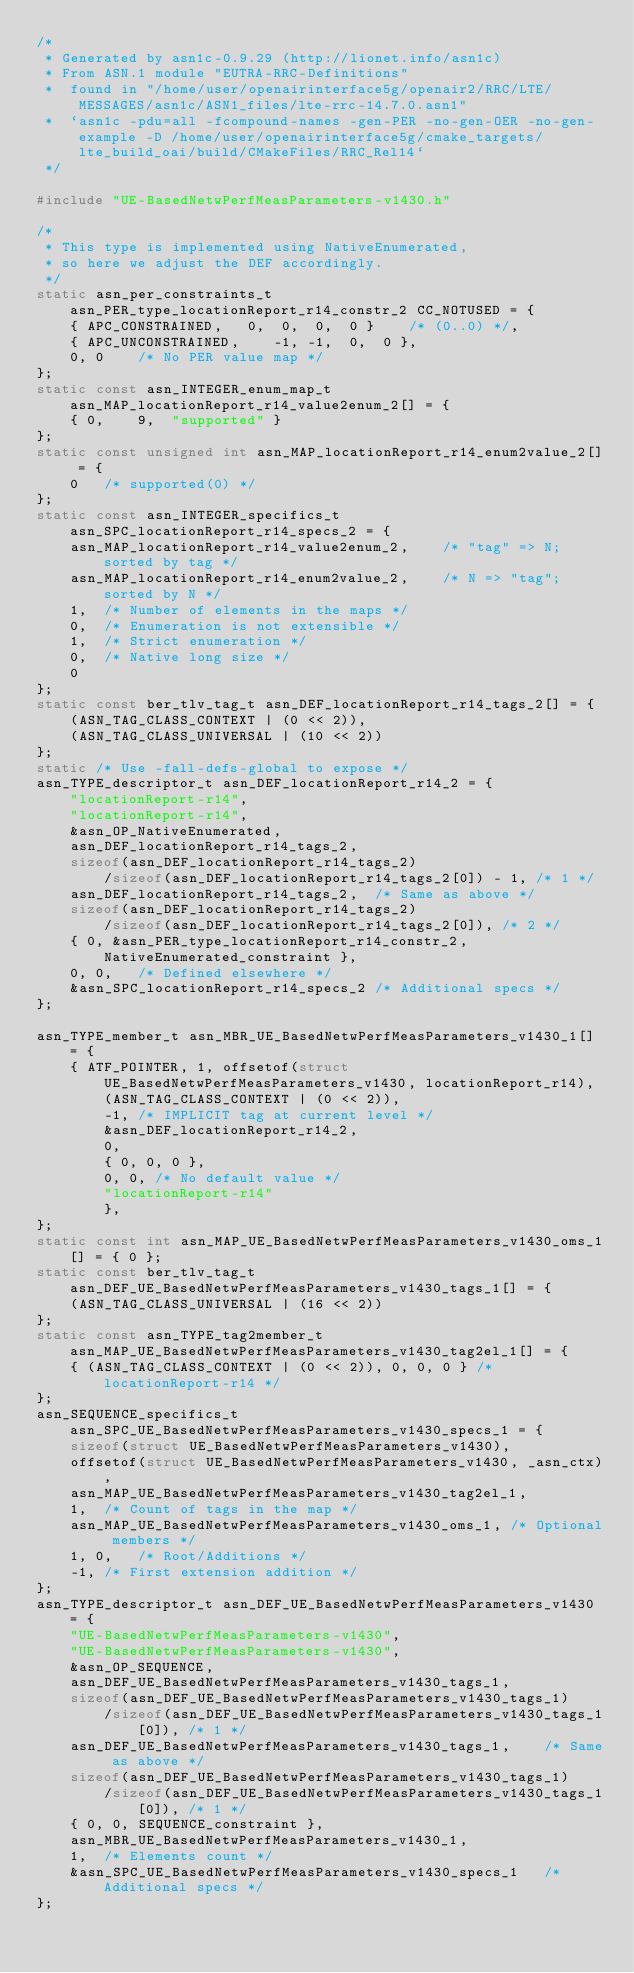<code> <loc_0><loc_0><loc_500><loc_500><_C_>/*
 * Generated by asn1c-0.9.29 (http://lionet.info/asn1c)
 * From ASN.1 module "EUTRA-RRC-Definitions"
 * 	found in "/home/user/openairinterface5g/openair2/RRC/LTE/MESSAGES/asn1c/ASN1_files/lte-rrc-14.7.0.asn1"
 * 	`asn1c -pdu=all -fcompound-names -gen-PER -no-gen-OER -no-gen-example -D /home/user/openairinterface5g/cmake_targets/lte_build_oai/build/CMakeFiles/RRC_Rel14`
 */

#include "UE-BasedNetwPerfMeasParameters-v1430.h"

/*
 * This type is implemented using NativeEnumerated,
 * so here we adjust the DEF accordingly.
 */
static asn_per_constraints_t asn_PER_type_locationReport_r14_constr_2 CC_NOTUSED = {
	{ APC_CONSTRAINED,	 0,  0,  0,  0 }	/* (0..0) */,
	{ APC_UNCONSTRAINED,	-1, -1,  0,  0 },
	0, 0	/* No PER value map */
};
static const asn_INTEGER_enum_map_t asn_MAP_locationReport_r14_value2enum_2[] = {
	{ 0,	9,	"supported" }
};
static const unsigned int asn_MAP_locationReport_r14_enum2value_2[] = {
	0	/* supported(0) */
};
static const asn_INTEGER_specifics_t asn_SPC_locationReport_r14_specs_2 = {
	asn_MAP_locationReport_r14_value2enum_2,	/* "tag" => N; sorted by tag */
	asn_MAP_locationReport_r14_enum2value_2,	/* N => "tag"; sorted by N */
	1,	/* Number of elements in the maps */
	0,	/* Enumeration is not extensible */
	1,	/* Strict enumeration */
	0,	/* Native long size */
	0
};
static const ber_tlv_tag_t asn_DEF_locationReport_r14_tags_2[] = {
	(ASN_TAG_CLASS_CONTEXT | (0 << 2)),
	(ASN_TAG_CLASS_UNIVERSAL | (10 << 2))
};
static /* Use -fall-defs-global to expose */
asn_TYPE_descriptor_t asn_DEF_locationReport_r14_2 = {
	"locationReport-r14",
	"locationReport-r14",
	&asn_OP_NativeEnumerated,
	asn_DEF_locationReport_r14_tags_2,
	sizeof(asn_DEF_locationReport_r14_tags_2)
		/sizeof(asn_DEF_locationReport_r14_tags_2[0]) - 1, /* 1 */
	asn_DEF_locationReport_r14_tags_2,	/* Same as above */
	sizeof(asn_DEF_locationReport_r14_tags_2)
		/sizeof(asn_DEF_locationReport_r14_tags_2[0]), /* 2 */
	{ 0, &asn_PER_type_locationReport_r14_constr_2, NativeEnumerated_constraint },
	0, 0,	/* Defined elsewhere */
	&asn_SPC_locationReport_r14_specs_2	/* Additional specs */
};

asn_TYPE_member_t asn_MBR_UE_BasedNetwPerfMeasParameters_v1430_1[] = {
	{ ATF_POINTER, 1, offsetof(struct UE_BasedNetwPerfMeasParameters_v1430, locationReport_r14),
		(ASN_TAG_CLASS_CONTEXT | (0 << 2)),
		-1,	/* IMPLICIT tag at current level */
		&asn_DEF_locationReport_r14_2,
		0,
		{ 0, 0, 0 },
		0, 0, /* No default value */
		"locationReport-r14"
		},
};
static const int asn_MAP_UE_BasedNetwPerfMeasParameters_v1430_oms_1[] = { 0 };
static const ber_tlv_tag_t asn_DEF_UE_BasedNetwPerfMeasParameters_v1430_tags_1[] = {
	(ASN_TAG_CLASS_UNIVERSAL | (16 << 2))
};
static const asn_TYPE_tag2member_t asn_MAP_UE_BasedNetwPerfMeasParameters_v1430_tag2el_1[] = {
    { (ASN_TAG_CLASS_CONTEXT | (0 << 2)), 0, 0, 0 } /* locationReport-r14 */
};
asn_SEQUENCE_specifics_t asn_SPC_UE_BasedNetwPerfMeasParameters_v1430_specs_1 = {
	sizeof(struct UE_BasedNetwPerfMeasParameters_v1430),
	offsetof(struct UE_BasedNetwPerfMeasParameters_v1430, _asn_ctx),
	asn_MAP_UE_BasedNetwPerfMeasParameters_v1430_tag2el_1,
	1,	/* Count of tags in the map */
	asn_MAP_UE_BasedNetwPerfMeasParameters_v1430_oms_1,	/* Optional members */
	1, 0,	/* Root/Additions */
	-1,	/* First extension addition */
};
asn_TYPE_descriptor_t asn_DEF_UE_BasedNetwPerfMeasParameters_v1430 = {
	"UE-BasedNetwPerfMeasParameters-v1430",
	"UE-BasedNetwPerfMeasParameters-v1430",
	&asn_OP_SEQUENCE,
	asn_DEF_UE_BasedNetwPerfMeasParameters_v1430_tags_1,
	sizeof(asn_DEF_UE_BasedNetwPerfMeasParameters_v1430_tags_1)
		/sizeof(asn_DEF_UE_BasedNetwPerfMeasParameters_v1430_tags_1[0]), /* 1 */
	asn_DEF_UE_BasedNetwPerfMeasParameters_v1430_tags_1,	/* Same as above */
	sizeof(asn_DEF_UE_BasedNetwPerfMeasParameters_v1430_tags_1)
		/sizeof(asn_DEF_UE_BasedNetwPerfMeasParameters_v1430_tags_1[0]), /* 1 */
	{ 0, 0, SEQUENCE_constraint },
	asn_MBR_UE_BasedNetwPerfMeasParameters_v1430_1,
	1,	/* Elements count */
	&asn_SPC_UE_BasedNetwPerfMeasParameters_v1430_specs_1	/* Additional specs */
};

</code> 